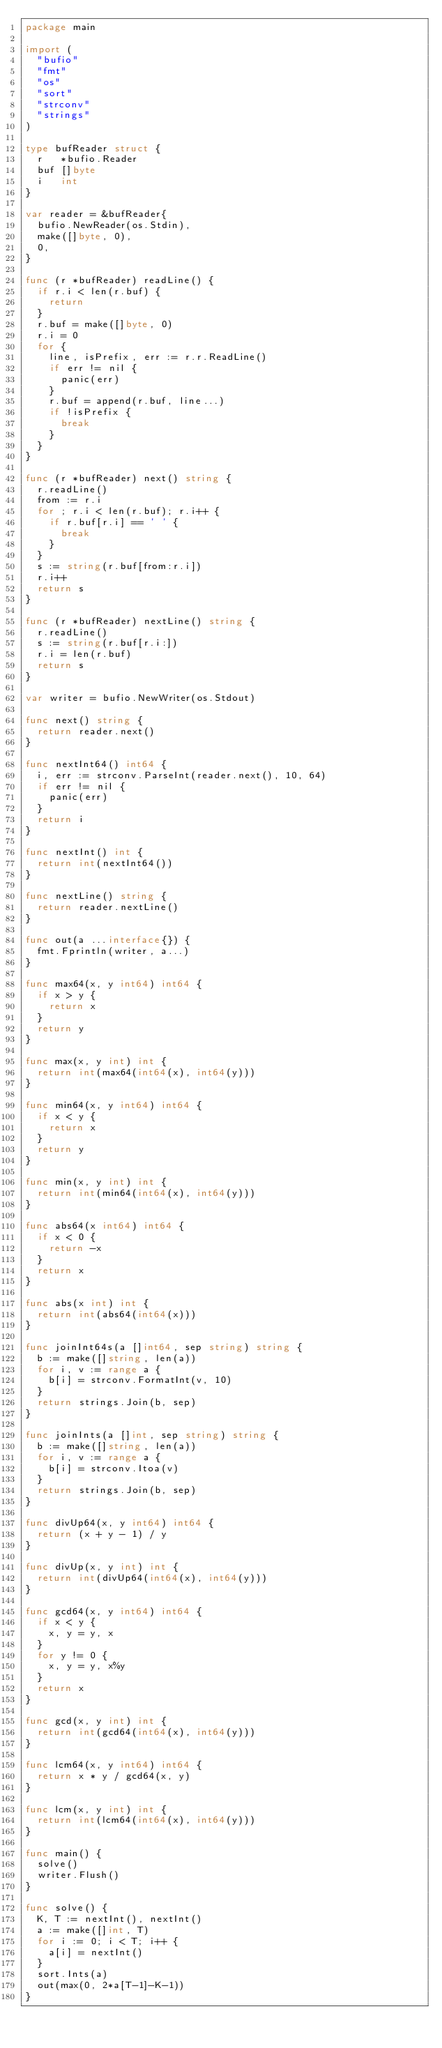<code> <loc_0><loc_0><loc_500><loc_500><_Go_>package main

import (
	"bufio"
	"fmt"
	"os"
	"sort"
	"strconv"
	"strings"
)

type bufReader struct {
	r   *bufio.Reader
	buf []byte
	i   int
}

var reader = &bufReader{
	bufio.NewReader(os.Stdin),
	make([]byte, 0),
	0,
}

func (r *bufReader) readLine() {
	if r.i < len(r.buf) {
		return
	}
	r.buf = make([]byte, 0)
	r.i = 0
	for {
		line, isPrefix, err := r.r.ReadLine()
		if err != nil {
			panic(err)
		}
		r.buf = append(r.buf, line...)
		if !isPrefix {
			break
		}
	}
}

func (r *bufReader) next() string {
	r.readLine()
	from := r.i
	for ; r.i < len(r.buf); r.i++ {
		if r.buf[r.i] == ' ' {
			break
		}
	}
	s := string(r.buf[from:r.i])
	r.i++
	return s
}

func (r *bufReader) nextLine() string {
	r.readLine()
	s := string(r.buf[r.i:])
	r.i = len(r.buf)
	return s
}

var writer = bufio.NewWriter(os.Stdout)

func next() string {
	return reader.next()
}

func nextInt64() int64 {
	i, err := strconv.ParseInt(reader.next(), 10, 64)
	if err != nil {
		panic(err)
	}
	return i
}

func nextInt() int {
	return int(nextInt64())
}

func nextLine() string {
	return reader.nextLine()
}

func out(a ...interface{}) {
	fmt.Fprintln(writer, a...)
}

func max64(x, y int64) int64 {
	if x > y {
		return x
	}
	return y
}

func max(x, y int) int {
	return int(max64(int64(x), int64(y)))
}

func min64(x, y int64) int64 {
	if x < y {
		return x
	}
	return y
}

func min(x, y int) int {
	return int(min64(int64(x), int64(y)))
}

func abs64(x int64) int64 {
	if x < 0 {
		return -x
	}
	return x
}

func abs(x int) int {
	return int(abs64(int64(x)))
}

func joinInt64s(a []int64, sep string) string {
	b := make([]string, len(a))
	for i, v := range a {
		b[i] = strconv.FormatInt(v, 10)
	}
	return strings.Join(b, sep)
}

func joinInts(a []int, sep string) string {
	b := make([]string, len(a))
	for i, v := range a {
		b[i] = strconv.Itoa(v)
	}
	return strings.Join(b, sep)
}

func divUp64(x, y int64) int64 {
	return (x + y - 1) / y
}

func divUp(x, y int) int {
	return int(divUp64(int64(x), int64(y)))
}

func gcd64(x, y int64) int64 {
	if x < y {
		x, y = y, x
	}
	for y != 0 {
		x, y = y, x%y
	}
	return x
}

func gcd(x, y int) int {
	return int(gcd64(int64(x), int64(y)))
}

func lcm64(x, y int64) int64 {
	return x * y / gcd64(x, y)
}

func lcm(x, y int) int {
	return int(lcm64(int64(x), int64(y)))
}

func main() {
	solve()
	writer.Flush()
}

func solve() {
	K, T := nextInt(), nextInt()
	a := make([]int, T)
	for i := 0; i < T; i++ {
		a[i] = nextInt()
	}
	sort.Ints(a)
	out(max(0, 2*a[T-1]-K-1))
}
</code> 